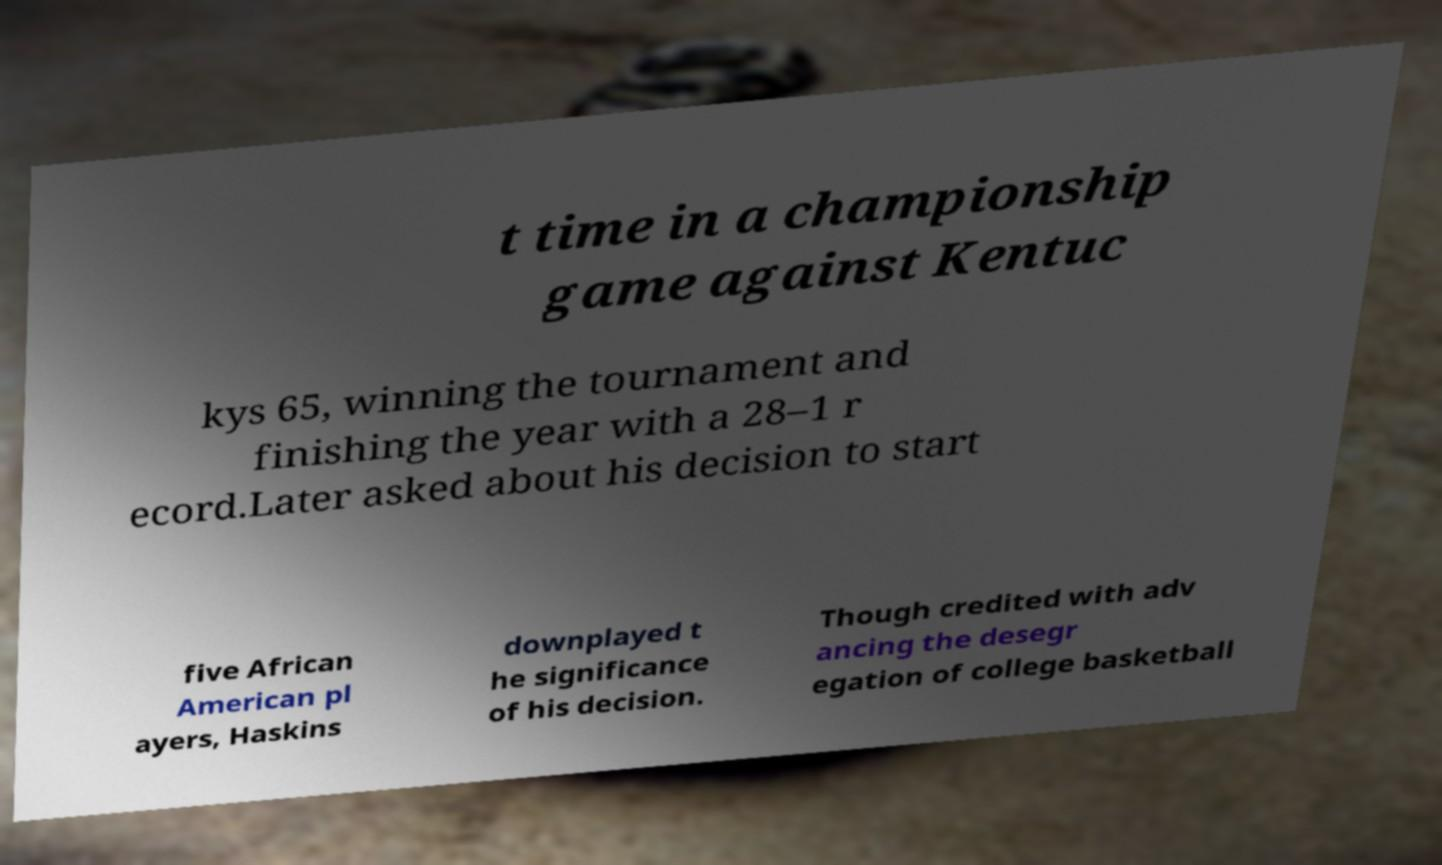What messages or text are displayed in this image? I need them in a readable, typed format. t time in a championship game against Kentuc kys 65, winning the tournament and finishing the year with a 28–1 r ecord.Later asked about his decision to start five African American pl ayers, Haskins downplayed t he significance of his decision. Though credited with adv ancing the desegr egation of college basketball 